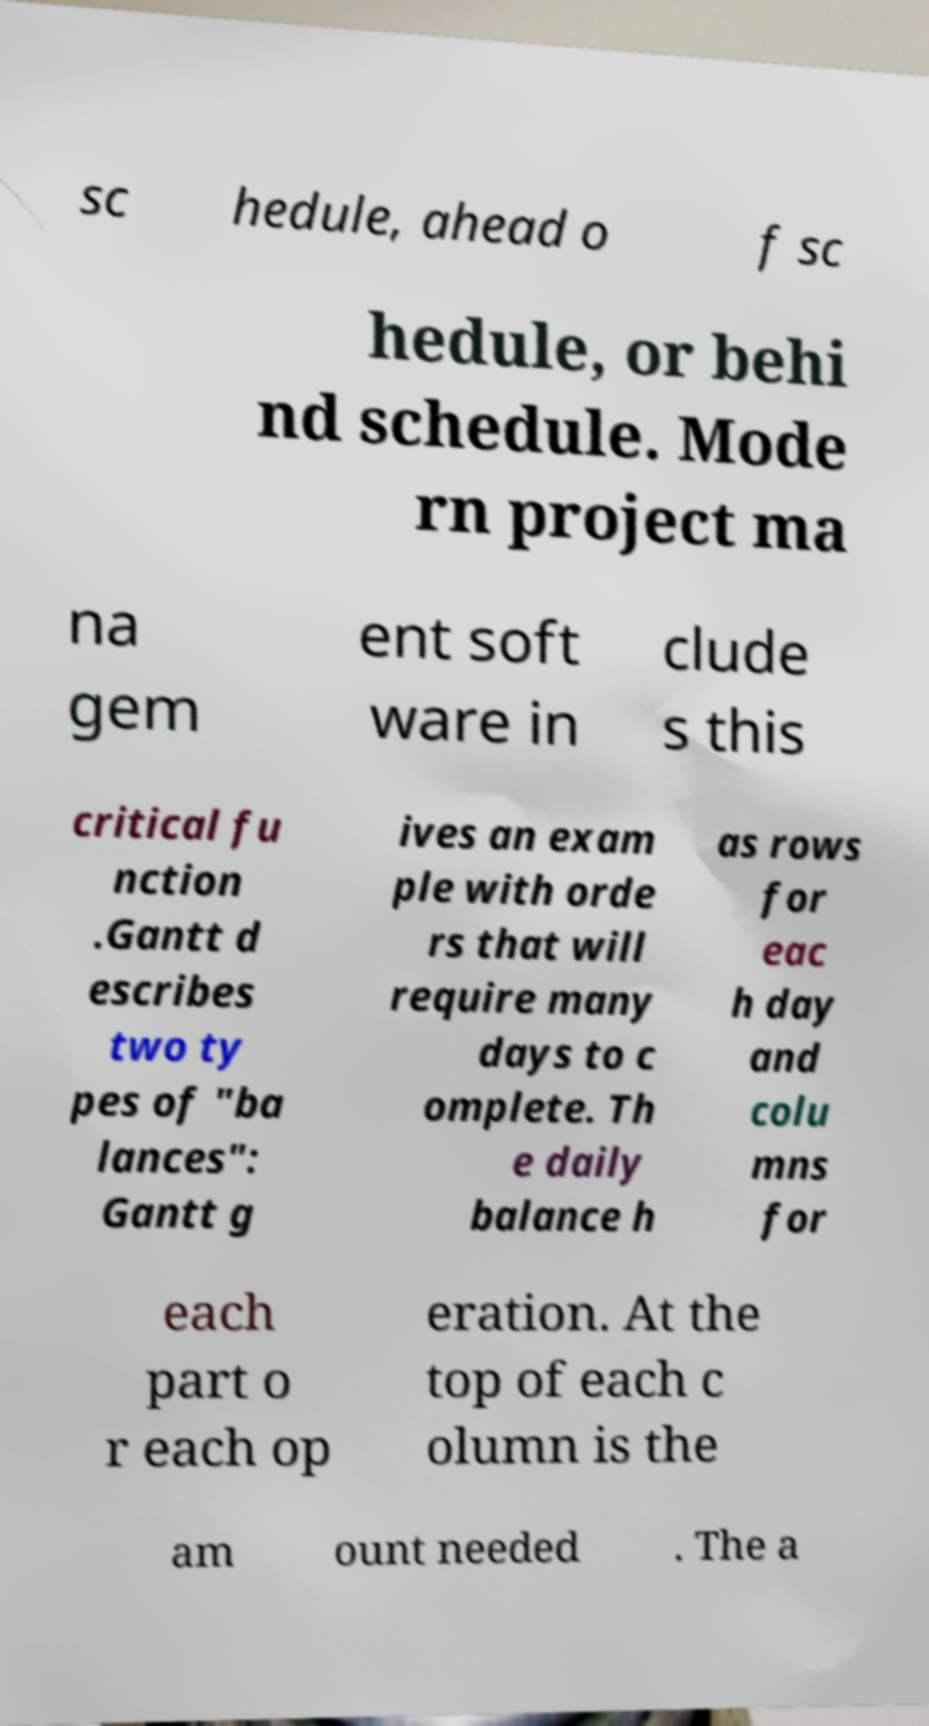Could you assist in decoding the text presented in this image and type it out clearly? sc hedule, ahead o f sc hedule, or behi nd schedule. Mode rn project ma na gem ent soft ware in clude s this critical fu nction .Gantt d escribes two ty pes of "ba lances": Gantt g ives an exam ple with orde rs that will require many days to c omplete. Th e daily balance h as rows for eac h day and colu mns for each part o r each op eration. At the top of each c olumn is the am ount needed . The a 